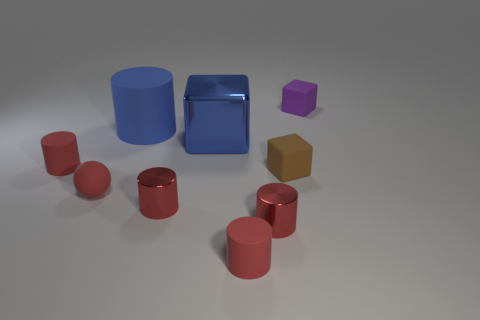Add 1 big gray rubber things. How many objects exist? 10 Subtract all red rubber cylinders. How many cylinders are left? 3 Subtract all red spheres. How many red cylinders are left? 4 Subtract 2 cylinders. How many cylinders are left? 3 Subtract all blue cylinders. How many cylinders are left? 4 Subtract all cylinders. How many objects are left? 4 Subtract all cyan cubes. Subtract all green balls. How many cubes are left? 3 Subtract all tiny red matte spheres. Subtract all tiny purple metallic things. How many objects are left? 8 Add 9 purple objects. How many purple objects are left? 10 Add 1 red rubber cylinders. How many red rubber cylinders exist? 3 